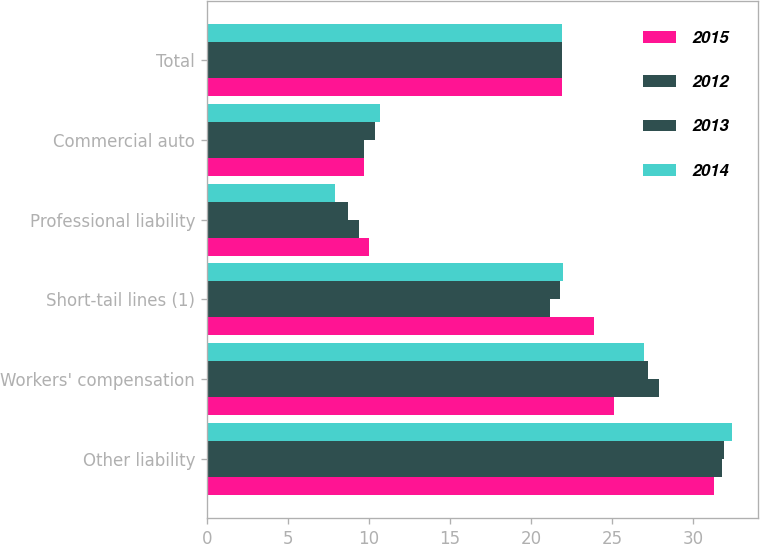Convert chart. <chart><loc_0><loc_0><loc_500><loc_500><stacked_bar_chart><ecel><fcel>Other liability<fcel>Workers' compensation<fcel>Short-tail lines (1)<fcel>Professional liability<fcel>Commercial auto<fcel>Total<nl><fcel>2015<fcel>31.3<fcel>25.1<fcel>23.9<fcel>10<fcel>9.7<fcel>21.9<nl><fcel>2012<fcel>31.8<fcel>27.9<fcel>21.2<fcel>9.4<fcel>9.7<fcel>21.9<nl><fcel>2013<fcel>31.9<fcel>27.2<fcel>21.8<fcel>8.7<fcel>10.4<fcel>21.9<nl><fcel>2014<fcel>32.4<fcel>27<fcel>22<fcel>7.9<fcel>10.7<fcel>21.9<nl></chart> 